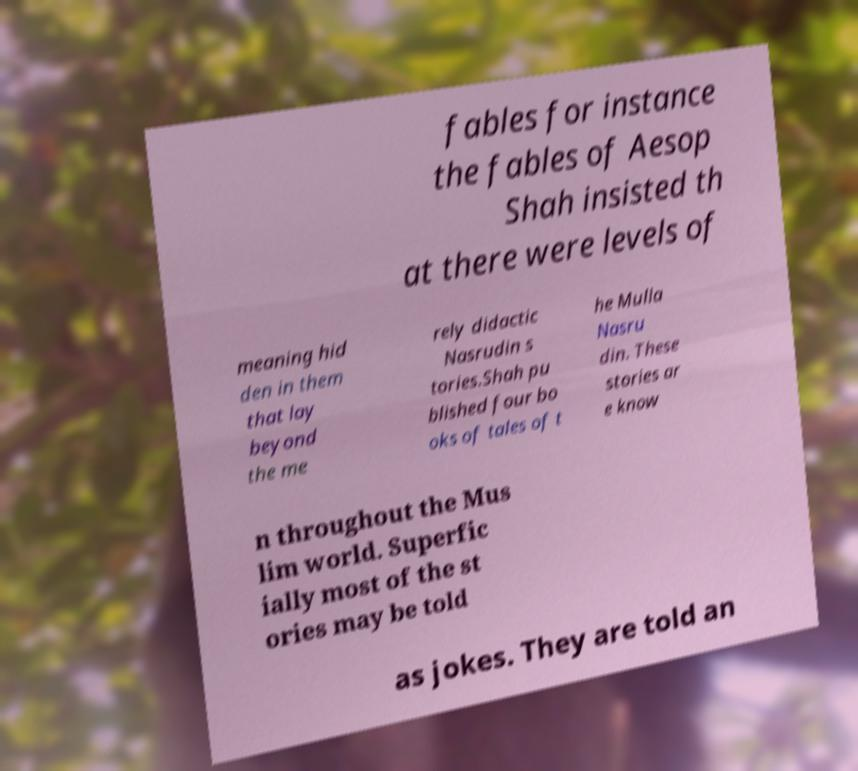There's text embedded in this image that I need extracted. Can you transcribe it verbatim? fables for instance the fables of Aesop Shah insisted th at there were levels of meaning hid den in them that lay beyond the me rely didactic Nasrudin s tories.Shah pu blished four bo oks of tales of t he Mulla Nasru din. These stories ar e know n throughout the Mus lim world. Superfic ially most of the st ories may be told as jokes. They are told an 